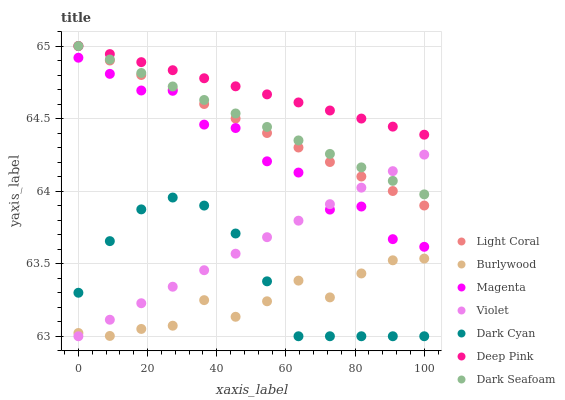Does Burlywood have the minimum area under the curve?
Answer yes or no. Yes. Does Deep Pink have the maximum area under the curve?
Answer yes or no. Yes. Does Light Coral have the minimum area under the curve?
Answer yes or no. No. Does Light Coral have the maximum area under the curve?
Answer yes or no. No. Is Deep Pink the smoothest?
Answer yes or no. Yes. Is Magenta the roughest?
Answer yes or no. Yes. Is Burlywood the smoothest?
Answer yes or no. No. Is Burlywood the roughest?
Answer yes or no. No. Does Violet have the lowest value?
Answer yes or no. Yes. Does Burlywood have the lowest value?
Answer yes or no. No. Does Dark Seafoam have the highest value?
Answer yes or no. Yes. Does Burlywood have the highest value?
Answer yes or no. No. Is Burlywood less than Magenta?
Answer yes or no. Yes. Is Deep Pink greater than Burlywood?
Answer yes or no. Yes. Does Dark Cyan intersect Burlywood?
Answer yes or no. Yes. Is Dark Cyan less than Burlywood?
Answer yes or no. No. Is Dark Cyan greater than Burlywood?
Answer yes or no. No. Does Burlywood intersect Magenta?
Answer yes or no. No. 